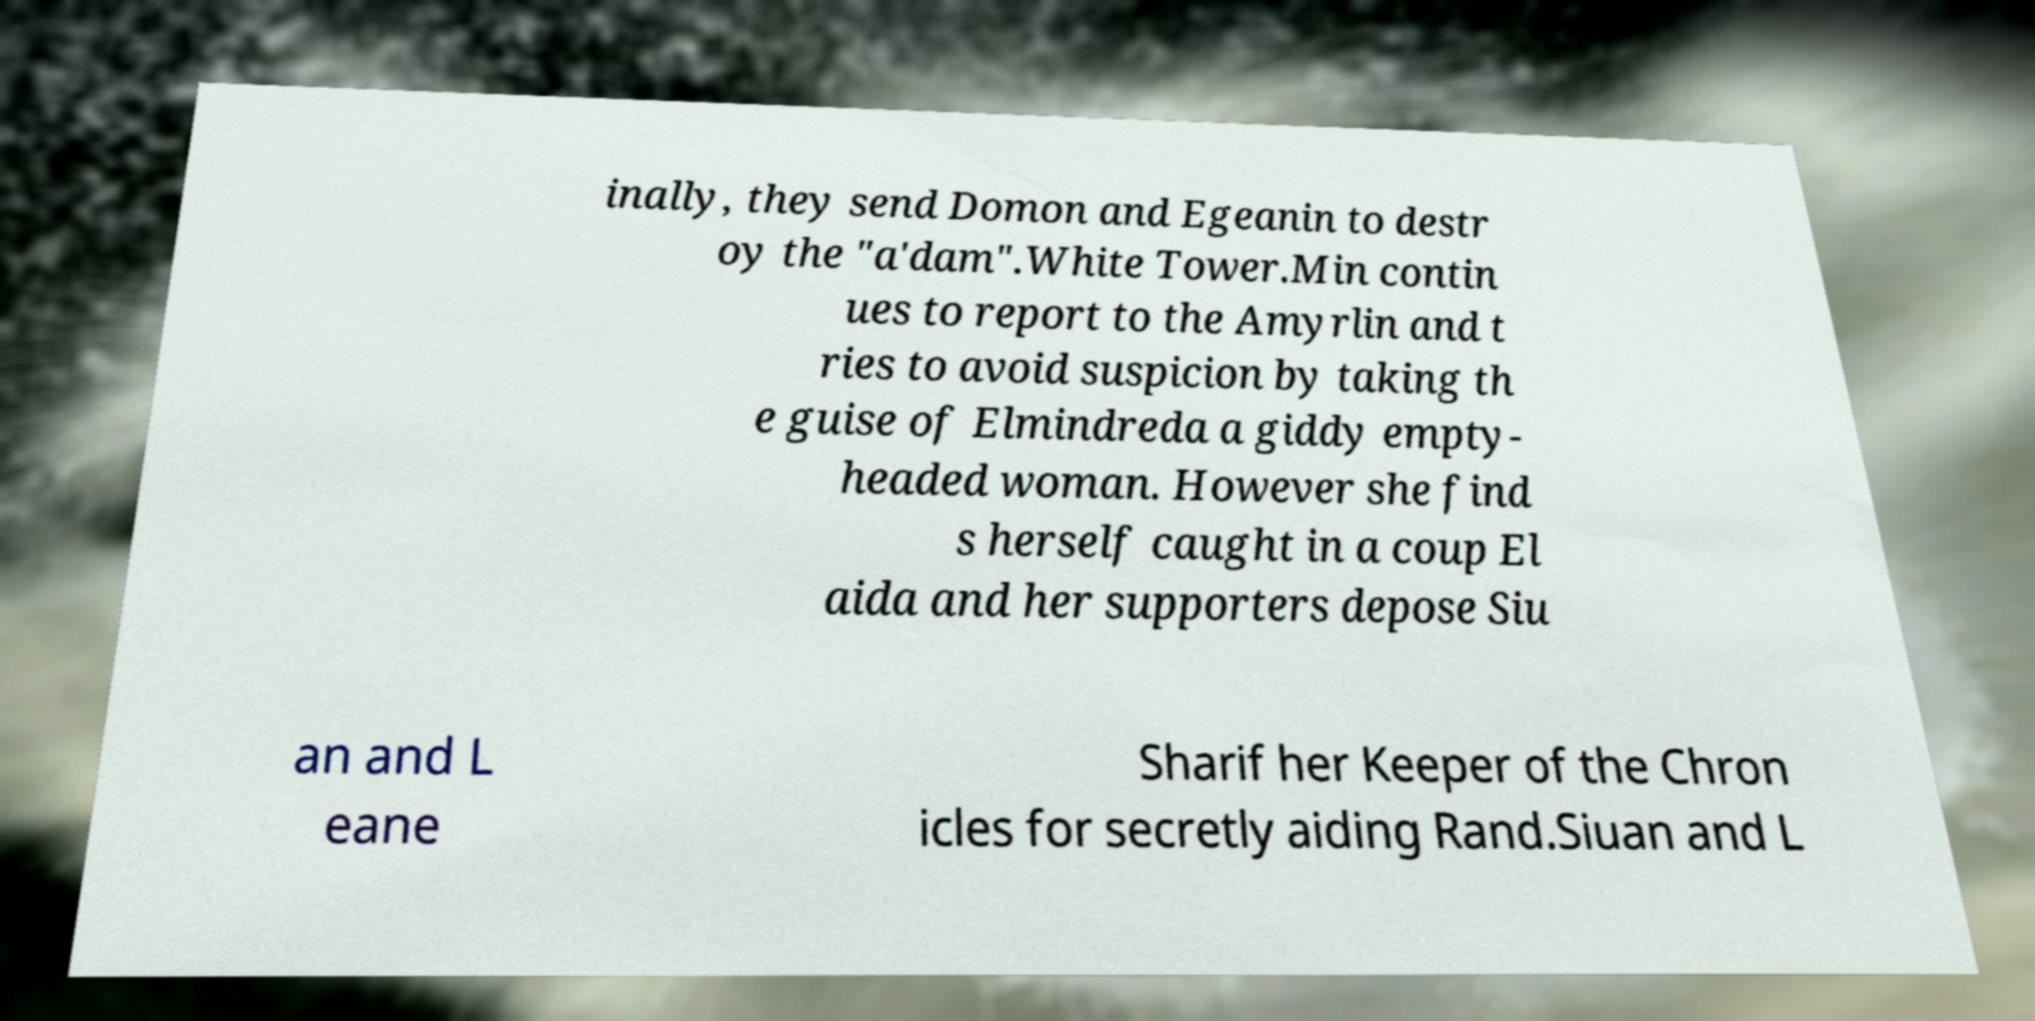For documentation purposes, I need the text within this image transcribed. Could you provide that? inally, they send Domon and Egeanin to destr oy the "a'dam".White Tower.Min contin ues to report to the Amyrlin and t ries to avoid suspicion by taking th e guise of Elmindreda a giddy empty- headed woman. However she find s herself caught in a coup El aida and her supporters depose Siu an and L eane Sharif her Keeper of the Chron icles for secretly aiding Rand.Siuan and L 